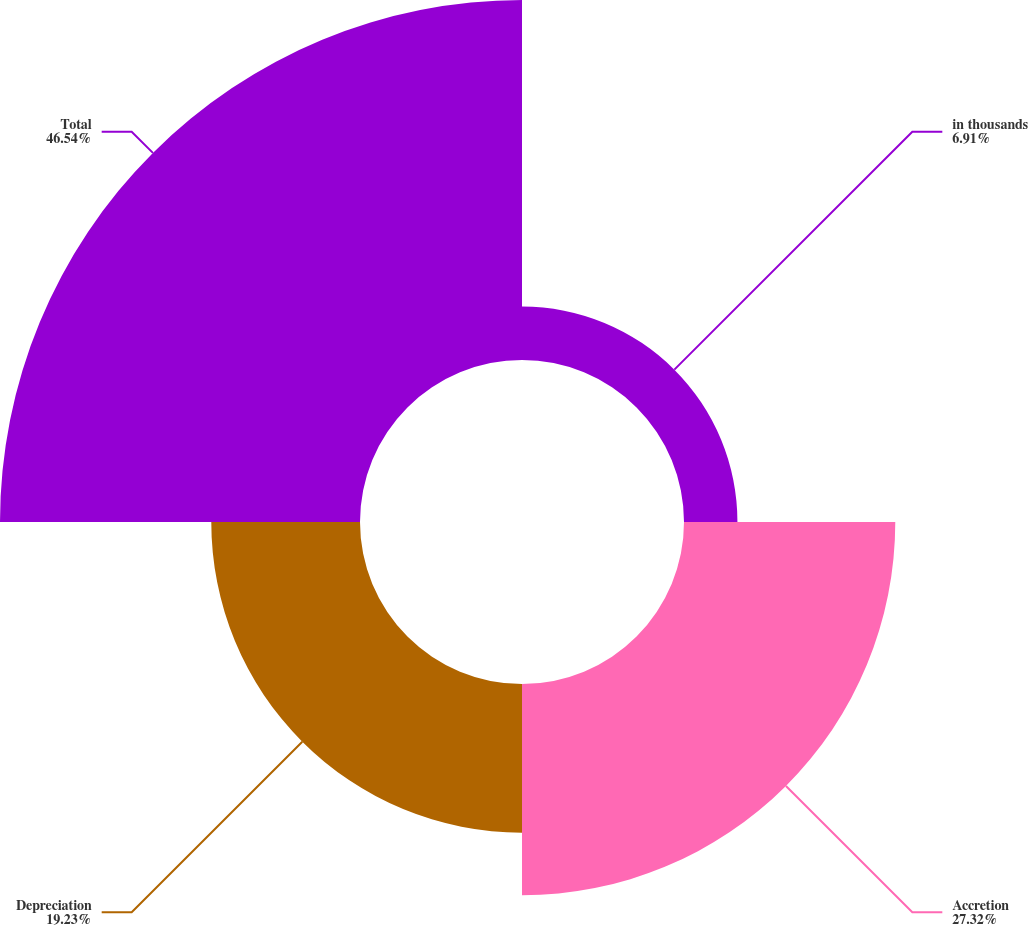<chart> <loc_0><loc_0><loc_500><loc_500><pie_chart><fcel>in thousands<fcel>Accretion<fcel>Depreciation<fcel>Total<nl><fcel>6.91%<fcel>27.32%<fcel>19.23%<fcel>46.55%<nl></chart> 